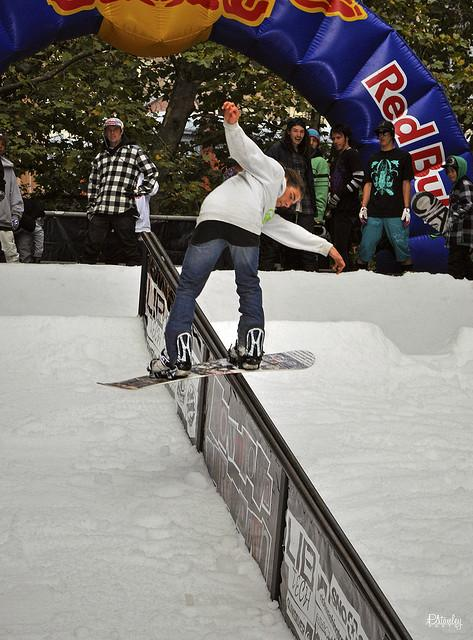What position does this player have the snowboards center point on the rail?

Choices:
A) flat
B) parallel
C) right turn
D) curved flat 